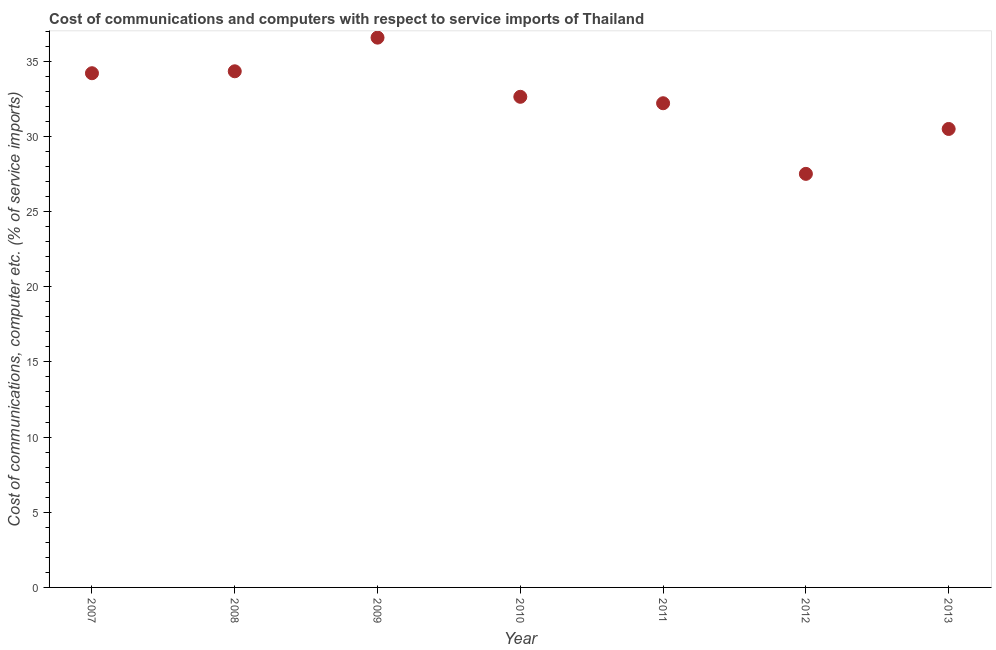What is the cost of communications and computer in 2012?
Your answer should be compact. 27.51. Across all years, what is the maximum cost of communications and computer?
Your response must be concise. 36.57. Across all years, what is the minimum cost of communications and computer?
Offer a very short reply. 27.51. What is the sum of the cost of communications and computer?
Provide a short and direct response. 227.92. What is the difference between the cost of communications and computer in 2011 and 2013?
Your response must be concise. 1.71. What is the average cost of communications and computer per year?
Keep it short and to the point. 32.56. What is the median cost of communications and computer?
Make the answer very short. 32.63. Do a majority of the years between 2013 and 2010 (inclusive) have cost of communications and computer greater than 7 %?
Make the answer very short. Yes. What is the ratio of the cost of communications and computer in 2008 to that in 2011?
Give a very brief answer. 1.07. What is the difference between the highest and the second highest cost of communications and computer?
Provide a succinct answer. 2.24. Is the sum of the cost of communications and computer in 2007 and 2008 greater than the maximum cost of communications and computer across all years?
Your answer should be compact. Yes. What is the difference between the highest and the lowest cost of communications and computer?
Make the answer very short. 9.06. In how many years, is the cost of communications and computer greater than the average cost of communications and computer taken over all years?
Give a very brief answer. 4. What is the difference between two consecutive major ticks on the Y-axis?
Your response must be concise. 5. Are the values on the major ticks of Y-axis written in scientific E-notation?
Your answer should be compact. No. Does the graph contain grids?
Keep it short and to the point. No. What is the title of the graph?
Offer a very short reply. Cost of communications and computers with respect to service imports of Thailand. What is the label or title of the X-axis?
Provide a succinct answer. Year. What is the label or title of the Y-axis?
Provide a short and direct response. Cost of communications, computer etc. (% of service imports). What is the Cost of communications, computer etc. (% of service imports) in 2007?
Give a very brief answer. 34.2. What is the Cost of communications, computer etc. (% of service imports) in 2008?
Ensure brevity in your answer.  34.33. What is the Cost of communications, computer etc. (% of service imports) in 2009?
Your answer should be compact. 36.57. What is the Cost of communications, computer etc. (% of service imports) in 2010?
Offer a terse response. 32.63. What is the Cost of communications, computer etc. (% of service imports) in 2011?
Offer a terse response. 32.2. What is the Cost of communications, computer etc. (% of service imports) in 2012?
Keep it short and to the point. 27.51. What is the Cost of communications, computer etc. (% of service imports) in 2013?
Offer a very short reply. 30.49. What is the difference between the Cost of communications, computer etc. (% of service imports) in 2007 and 2008?
Your response must be concise. -0.13. What is the difference between the Cost of communications, computer etc. (% of service imports) in 2007 and 2009?
Provide a succinct answer. -2.37. What is the difference between the Cost of communications, computer etc. (% of service imports) in 2007 and 2010?
Ensure brevity in your answer.  1.57. What is the difference between the Cost of communications, computer etc. (% of service imports) in 2007 and 2011?
Keep it short and to the point. 2. What is the difference between the Cost of communications, computer etc. (% of service imports) in 2007 and 2012?
Provide a succinct answer. 6.69. What is the difference between the Cost of communications, computer etc. (% of service imports) in 2007 and 2013?
Give a very brief answer. 3.71. What is the difference between the Cost of communications, computer etc. (% of service imports) in 2008 and 2009?
Offer a terse response. -2.24. What is the difference between the Cost of communications, computer etc. (% of service imports) in 2008 and 2010?
Offer a very short reply. 1.7. What is the difference between the Cost of communications, computer etc. (% of service imports) in 2008 and 2011?
Provide a succinct answer. 2.12. What is the difference between the Cost of communications, computer etc. (% of service imports) in 2008 and 2012?
Ensure brevity in your answer.  6.82. What is the difference between the Cost of communications, computer etc. (% of service imports) in 2008 and 2013?
Your response must be concise. 3.84. What is the difference between the Cost of communications, computer etc. (% of service imports) in 2009 and 2010?
Provide a short and direct response. 3.93. What is the difference between the Cost of communications, computer etc. (% of service imports) in 2009 and 2011?
Your response must be concise. 4.36. What is the difference between the Cost of communications, computer etc. (% of service imports) in 2009 and 2012?
Give a very brief answer. 9.06. What is the difference between the Cost of communications, computer etc. (% of service imports) in 2009 and 2013?
Your answer should be very brief. 6.07. What is the difference between the Cost of communications, computer etc. (% of service imports) in 2010 and 2011?
Give a very brief answer. 0.43. What is the difference between the Cost of communications, computer etc. (% of service imports) in 2010 and 2012?
Offer a very short reply. 5.13. What is the difference between the Cost of communications, computer etc. (% of service imports) in 2010 and 2013?
Keep it short and to the point. 2.14. What is the difference between the Cost of communications, computer etc. (% of service imports) in 2011 and 2012?
Keep it short and to the point. 4.7. What is the difference between the Cost of communications, computer etc. (% of service imports) in 2011 and 2013?
Your answer should be very brief. 1.71. What is the difference between the Cost of communications, computer etc. (% of service imports) in 2012 and 2013?
Give a very brief answer. -2.99. What is the ratio of the Cost of communications, computer etc. (% of service imports) in 2007 to that in 2008?
Ensure brevity in your answer.  1. What is the ratio of the Cost of communications, computer etc. (% of service imports) in 2007 to that in 2009?
Ensure brevity in your answer.  0.94. What is the ratio of the Cost of communications, computer etc. (% of service imports) in 2007 to that in 2010?
Provide a succinct answer. 1.05. What is the ratio of the Cost of communications, computer etc. (% of service imports) in 2007 to that in 2011?
Provide a succinct answer. 1.06. What is the ratio of the Cost of communications, computer etc. (% of service imports) in 2007 to that in 2012?
Give a very brief answer. 1.24. What is the ratio of the Cost of communications, computer etc. (% of service imports) in 2007 to that in 2013?
Provide a succinct answer. 1.12. What is the ratio of the Cost of communications, computer etc. (% of service imports) in 2008 to that in 2009?
Make the answer very short. 0.94. What is the ratio of the Cost of communications, computer etc. (% of service imports) in 2008 to that in 2010?
Provide a succinct answer. 1.05. What is the ratio of the Cost of communications, computer etc. (% of service imports) in 2008 to that in 2011?
Your answer should be very brief. 1.07. What is the ratio of the Cost of communications, computer etc. (% of service imports) in 2008 to that in 2012?
Offer a very short reply. 1.25. What is the ratio of the Cost of communications, computer etc. (% of service imports) in 2008 to that in 2013?
Ensure brevity in your answer.  1.13. What is the ratio of the Cost of communications, computer etc. (% of service imports) in 2009 to that in 2010?
Provide a short and direct response. 1.12. What is the ratio of the Cost of communications, computer etc. (% of service imports) in 2009 to that in 2011?
Offer a terse response. 1.14. What is the ratio of the Cost of communications, computer etc. (% of service imports) in 2009 to that in 2012?
Make the answer very short. 1.33. What is the ratio of the Cost of communications, computer etc. (% of service imports) in 2009 to that in 2013?
Give a very brief answer. 1.2. What is the ratio of the Cost of communications, computer etc. (% of service imports) in 2010 to that in 2011?
Offer a very short reply. 1.01. What is the ratio of the Cost of communications, computer etc. (% of service imports) in 2010 to that in 2012?
Ensure brevity in your answer.  1.19. What is the ratio of the Cost of communications, computer etc. (% of service imports) in 2010 to that in 2013?
Give a very brief answer. 1.07. What is the ratio of the Cost of communications, computer etc. (% of service imports) in 2011 to that in 2012?
Your answer should be compact. 1.17. What is the ratio of the Cost of communications, computer etc. (% of service imports) in 2011 to that in 2013?
Offer a terse response. 1.06. What is the ratio of the Cost of communications, computer etc. (% of service imports) in 2012 to that in 2013?
Your answer should be compact. 0.9. 